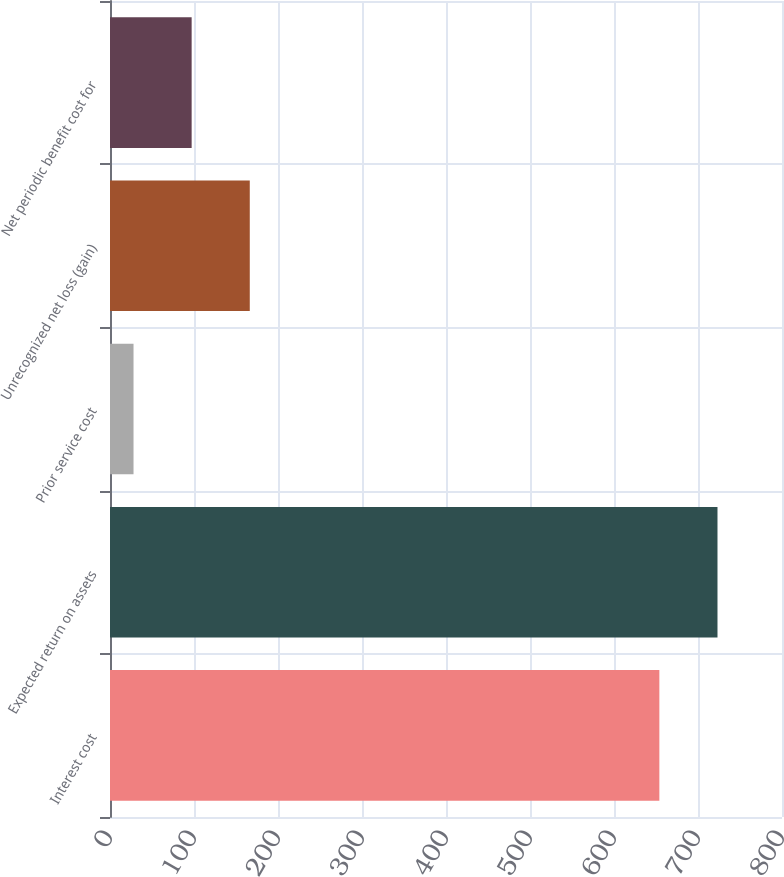Convert chart. <chart><loc_0><loc_0><loc_500><loc_500><bar_chart><fcel>Interest cost<fcel>Expected return on assets<fcel>Prior service cost<fcel>Unrecognized net loss (gain)<fcel>Net periodic benefit cost for<nl><fcel>654<fcel>723.2<fcel>28<fcel>166.4<fcel>97.2<nl></chart> 